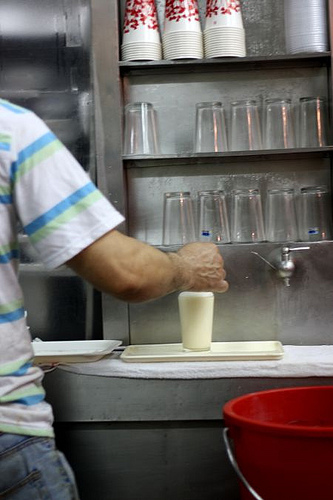<image>
Can you confirm if the drink is in the cup? No. The drink is not contained within the cup. These objects have a different spatial relationship. 